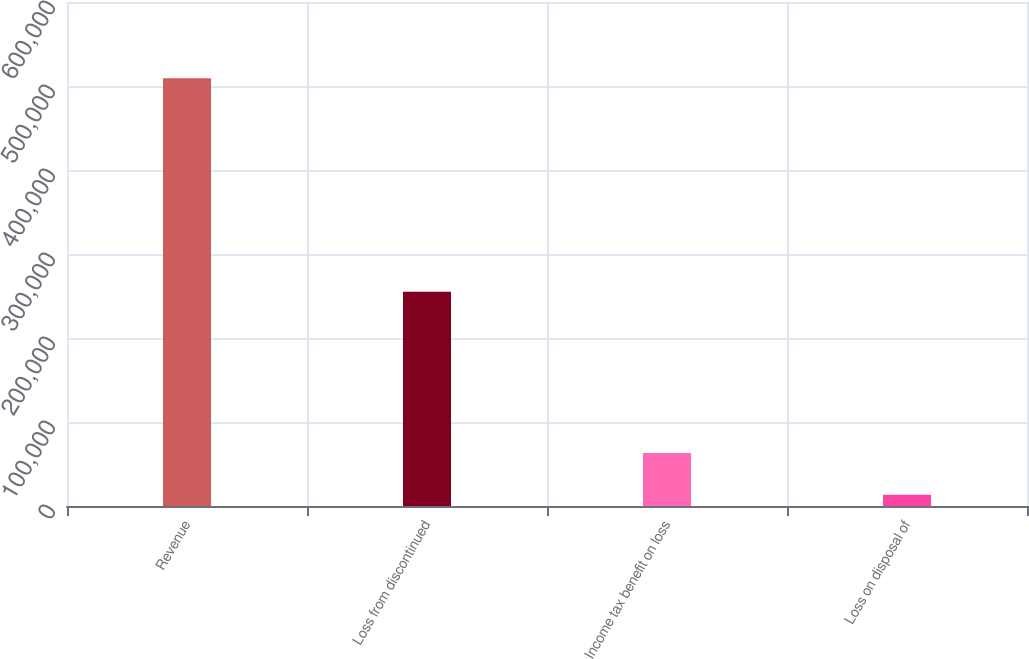Convert chart to OTSL. <chart><loc_0><loc_0><loc_500><loc_500><bar_chart><fcel>Revenue<fcel>Loss from discontinued<fcel>Income tax benefit on loss<fcel>Loss on disposal of<nl><fcel>509341<fcel>255119<fcel>63093.1<fcel>13510<nl></chart> 